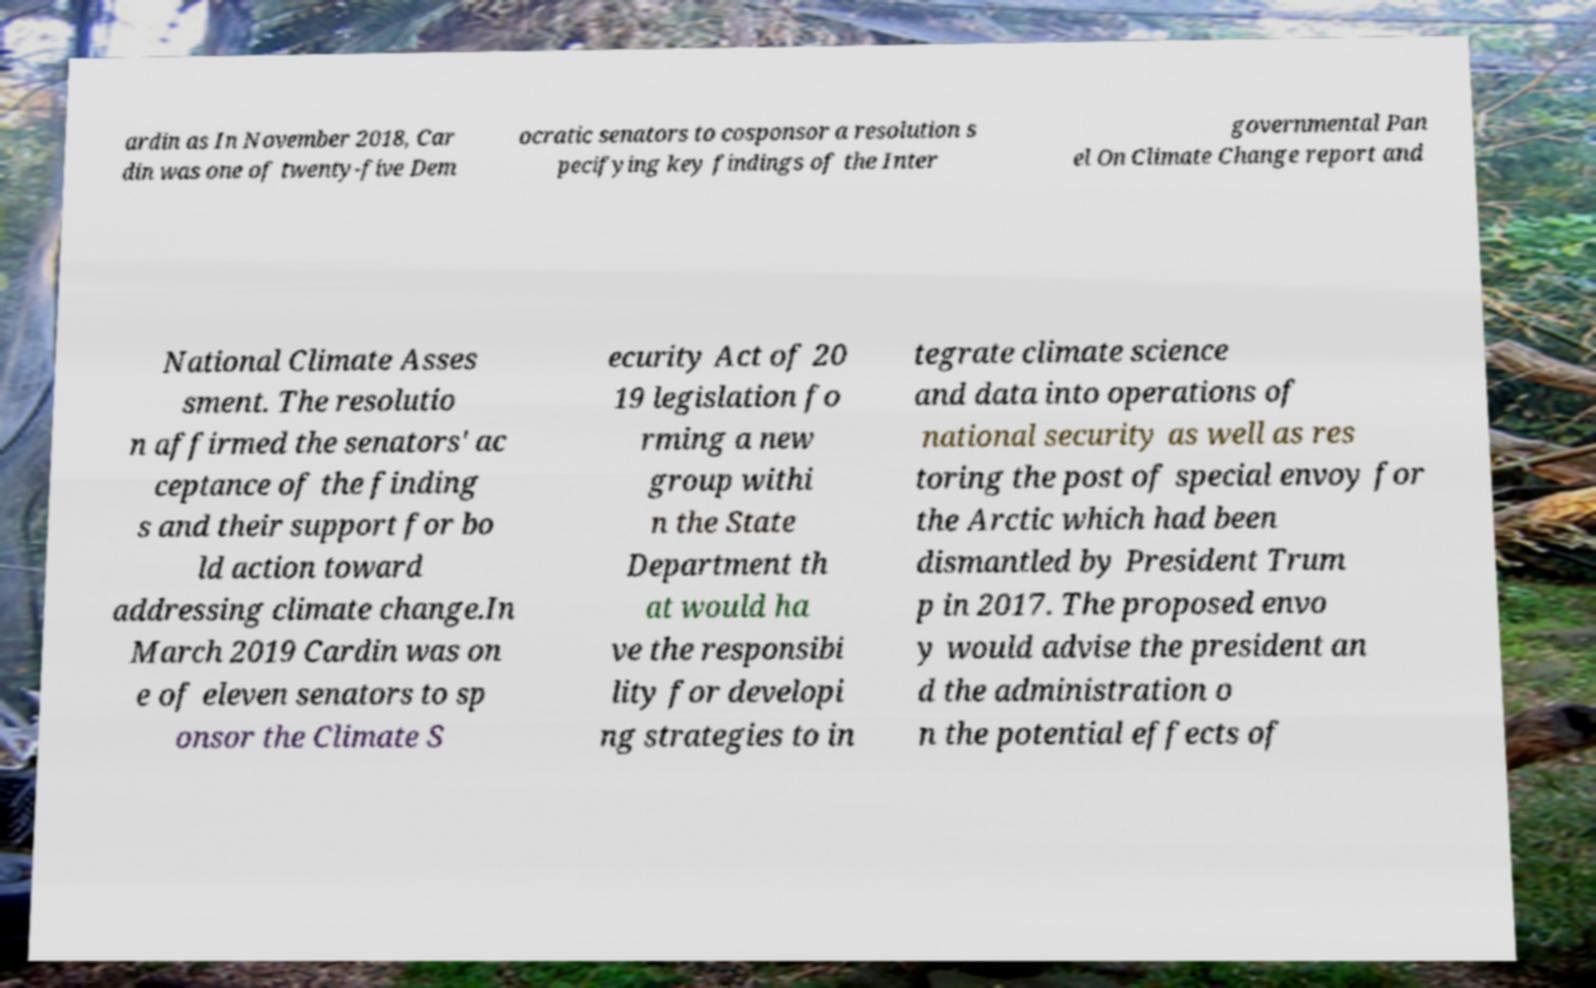There's text embedded in this image that I need extracted. Can you transcribe it verbatim? ardin as In November 2018, Car din was one of twenty-five Dem ocratic senators to cosponsor a resolution s pecifying key findings of the Inter governmental Pan el On Climate Change report and National Climate Asses sment. The resolutio n affirmed the senators' ac ceptance of the finding s and their support for bo ld action toward addressing climate change.In March 2019 Cardin was on e of eleven senators to sp onsor the Climate S ecurity Act of 20 19 legislation fo rming a new group withi n the State Department th at would ha ve the responsibi lity for developi ng strategies to in tegrate climate science and data into operations of national security as well as res toring the post of special envoy for the Arctic which had been dismantled by President Trum p in 2017. The proposed envo y would advise the president an d the administration o n the potential effects of 